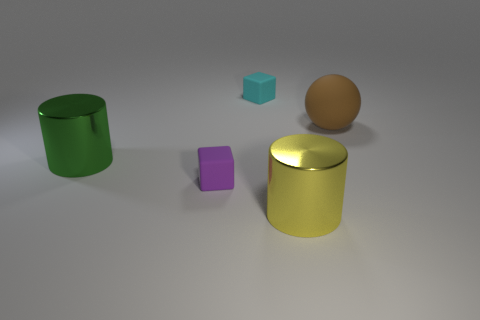Add 3 big yellow cylinders. How many objects exist? 8 Subtract all gray blocks. Subtract all green balls. How many blocks are left? 2 Subtract all cylinders. How many objects are left? 3 Add 5 big yellow shiny things. How many big yellow shiny things are left? 6 Add 4 cylinders. How many cylinders exist? 6 Subtract 0 cyan cylinders. How many objects are left? 5 Subtract all large gray matte things. Subtract all yellow shiny objects. How many objects are left? 4 